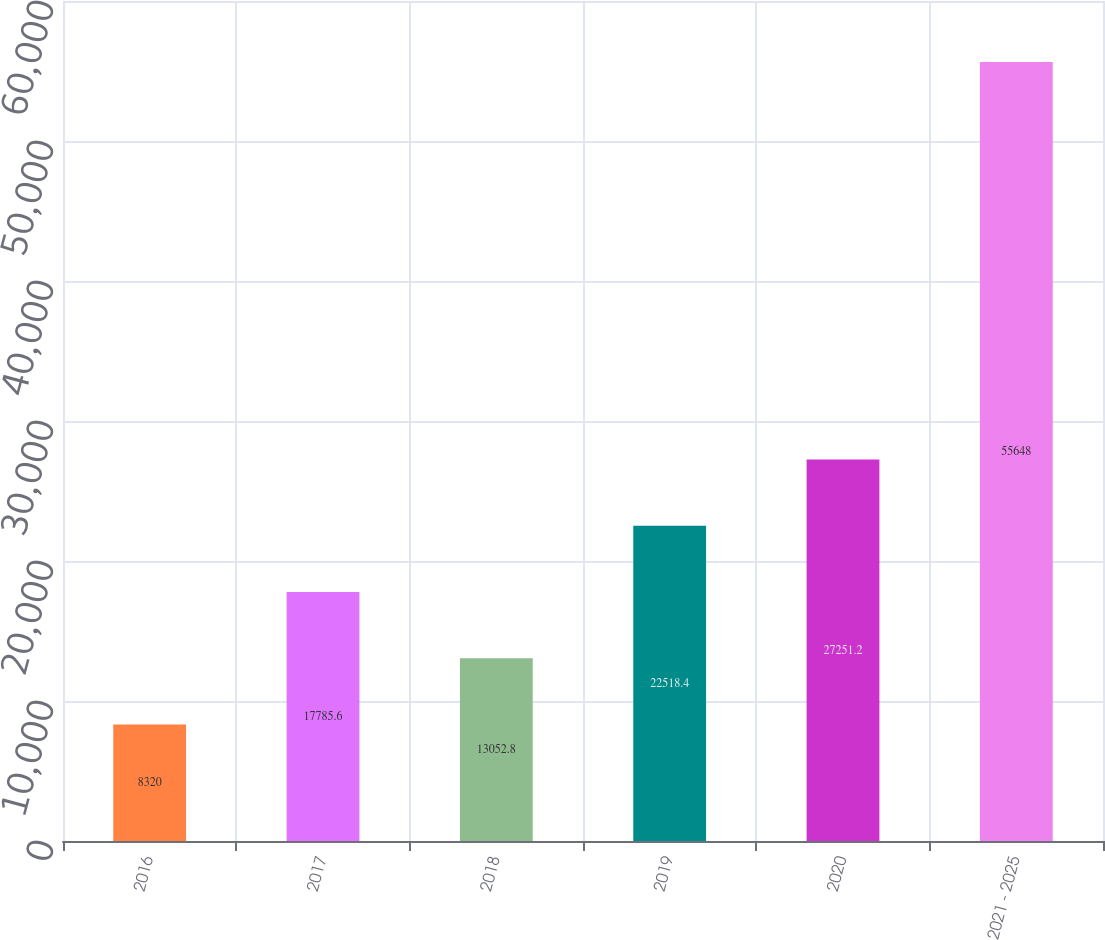Convert chart to OTSL. <chart><loc_0><loc_0><loc_500><loc_500><bar_chart><fcel>2016<fcel>2017<fcel>2018<fcel>2019<fcel>2020<fcel>2021 - 2025<nl><fcel>8320<fcel>17785.6<fcel>13052.8<fcel>22518.4<fcel>27251.2<fcel>55648<nl></chart> 